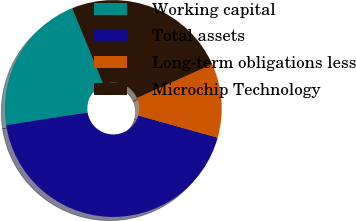Convert chart. <chart><loc_0><loc_0><loc_500><loc_500><pie_chart><fcel>Working capital<fcel>Total assets<fcel>Long-term obligations less<fcel>Microchip Technology<nl><fcel>21.26%<fcel>43.22%<fcel>11.04%<fcel>24.48%<nl></chart> 